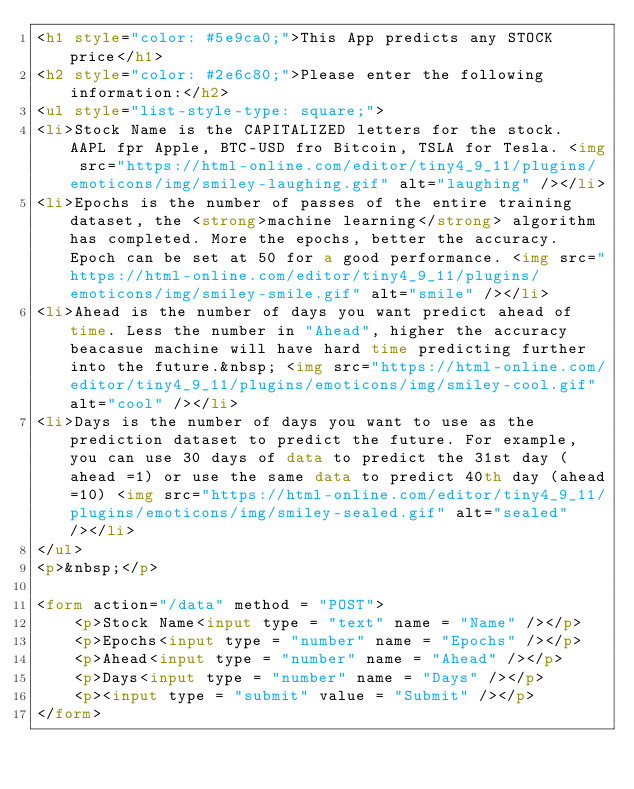Convert code to text. <code><loc_0><loc_0><loc_500><loc_500><_HTML_><h1 style="color: #5e9ca0;">This App predicts any STOCK price</h1>
<h2 style="color: #2e6c80;">Please enter the following information:</h2>
<ul style="list-style-type: square;">
<li>Stock Name is the CAPITALIZED letters for the stock. AAPL fpr Apple, BTC-USD fro Bitcoin, TSLA for Tesla. <img src="https://html-online.com/editor/tiny4_9_11/plugins/emoticons/img/smiley-laughing.gif" alt="laughing" /></li>
<li>Epochs is the number of passes of the entire training dataset, the <strong>machine learning</strong> algorithm has completed. More the epochs, better the accuracy. Epoch can be set at 50 for a good performance. <img src="https://html-online.com/editor/tiny4_9_11/plugins/emoticons/img/smiley-smile.gif" alt="smile" /></li>
<li>Ahead is the number of days you want predict ahead of time. Less the number in "Ahead", higher the accuracy beacasue machine will have hard time predicting further into the future.&nbsp; <img src="https://html-online.com/editor/tiny4_9_11/plugins/emoticons/img/smiley-cool.gif" alt="cool" /></li>
<li>Days is the number of days you want to use as the prediction dataset to predict the future. For example, you can use 30 days of data to predict the 31st day (ahead =1) or use the same data to predict 40th day (ahead=10) <img src="https://html-online.com/editor/tiny4_9_11/plugins/emoticons/img/smiley-sealed.gif" alt="sealed" /></li>
</ul>
<p>&nbsp;</p>

<form action="/data" method = "POST">
    <p>Stock Name<input type = "text" name = "Name" /></p>
    <p>Epochs<input type = "number" name = "Epochs" /></p>
    <p>Ahead<input type = "number" name = "Ahead" /></p>
    <p>Days<input type = "number" name = "Days" /></p>
    <p><input type = "submit" value = "Submit" /></p>
</form>
</code> 